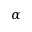<formula> <loc_0><loc_0><loc_500><loc_500>\alpha</formula> 